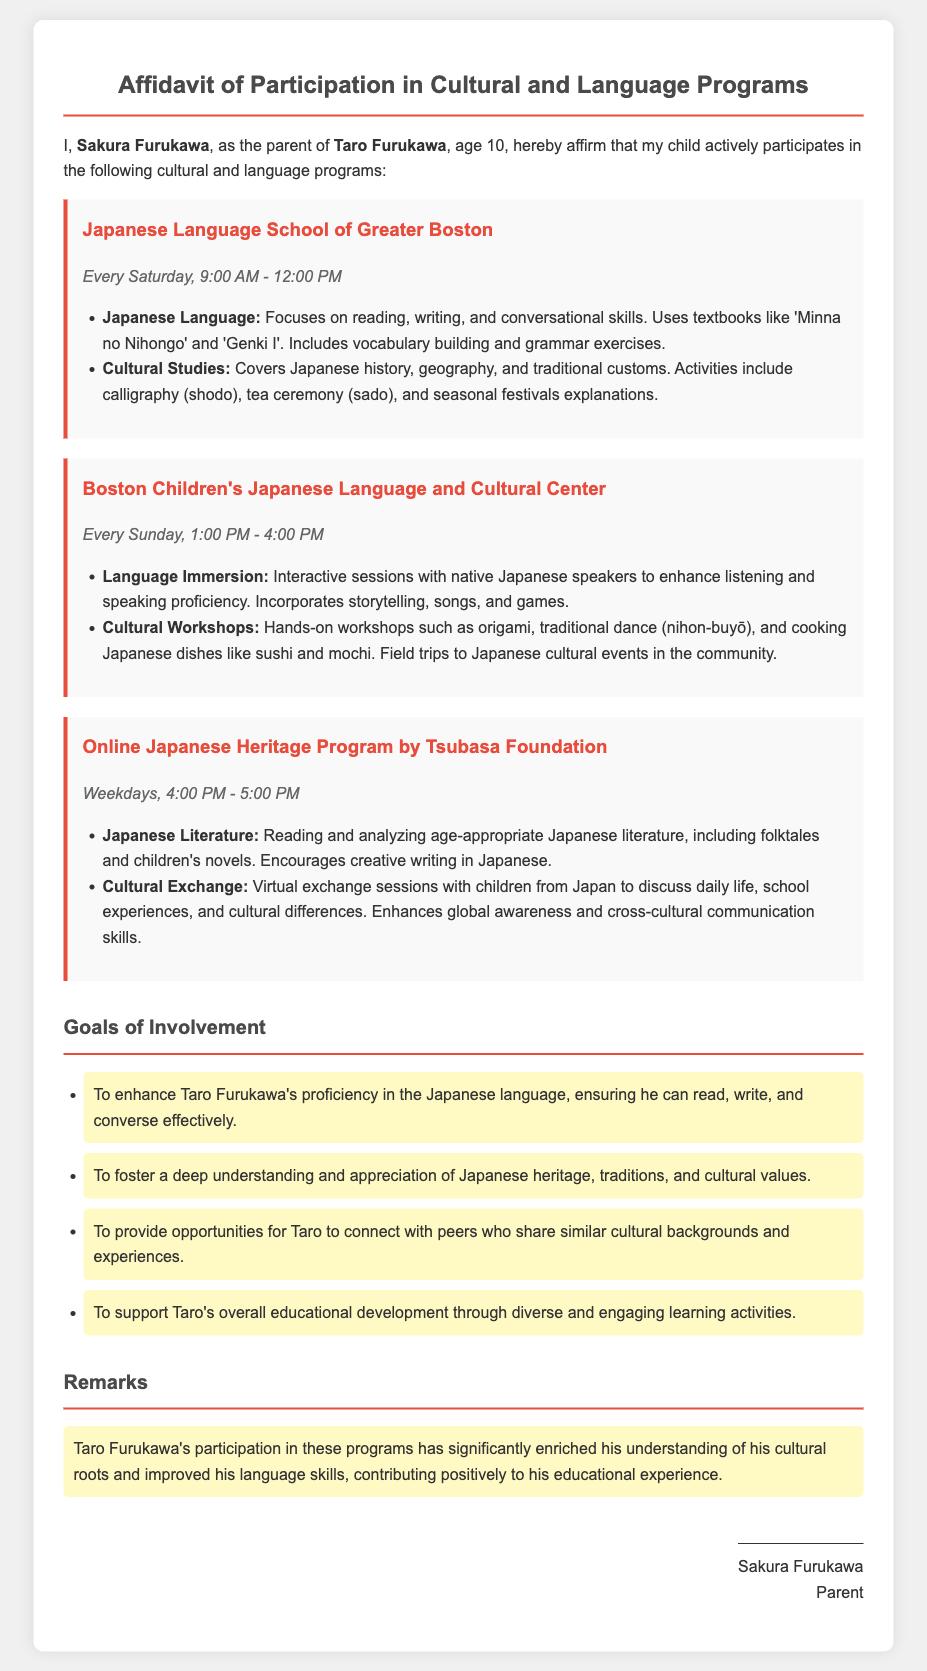What is the name of the child participating in the programs? The document states that the child's name is Taro Furukawa.
Answer: Taro Furukawa How old is Taro Furukawa? The affidavit mentions that Taro Furukawa is 10 years old.
Answer: 10 What is the focus of the Japanese Language program? The document outlines that the focus is on reading, writing, and conversational skills.
Answer: Reading, writing, and conversational skills Which program includes hands-on workshops? The Boston Children's Japanese Language and Cultural Center offers hands-on workshops.
Answer: Boston Children's Japanese Language and Cultural Center What time does the Online Japanese Heritage Program take place? The schedule indicates that the program takes place from 4:00 PM to 5:00 PM on weekdays.
Answer: 4:00 PM - 5:00 PM What are two goals of Taro's involvement in the programs? Two stated goals include enhancing Japanese language proficiency and fostering understanding of Japanese heritage.
Answer: Enhance language proficiency, foster understanding of Japanese heritage How often does Taro attend the Japanese Language School of Greater Boston? The affidavit specifies that Taro attends every Saturday.
Answer: Every Saturday What types of cultural activities are included in the programs? The document lists activities like calligraphy, tea ceremony, and origami.
Answer: Calligraphy, tea ceremony, origami Who signed the affidavit? The document shows that the affidavit was signed by Sakura Furukawa.
Answer: Sakura Furukawa 